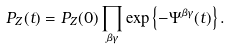<formula> <loc_0><loc_0><loc_500><loc_500>P _ { Z } ( t ) = P _ { Z } ( 0 ) \prod _ { \beta \gamma } \exp \left \{ - \Psi ^ { \beta \gamma } ( t ) \right \} .</formula> 